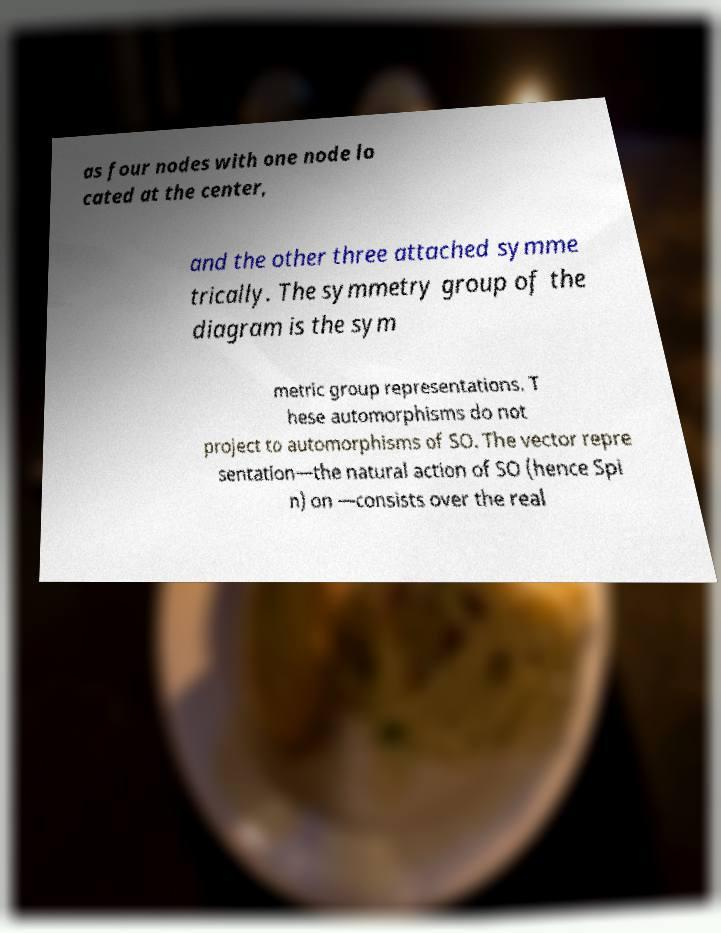What messages or text are displayed in this image? I need them in a readable, typed format. as four nodes with one node lo cated at the center, and the other three attached symme trically. The symmetry group of the diagram is the sym metric group representations. T hese automorphisms do not project to automorphisms of SO. The vector repre sentation—the natural action of SO (hence Spi n) on —consists over the real 